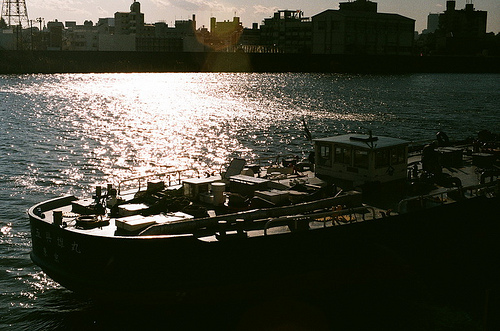What might the weather conditions be like in this photo? The weather appears clear and sunny with visible white clouds, suggesting a pleasant and calm day ideal for outdoor activities on the water. 